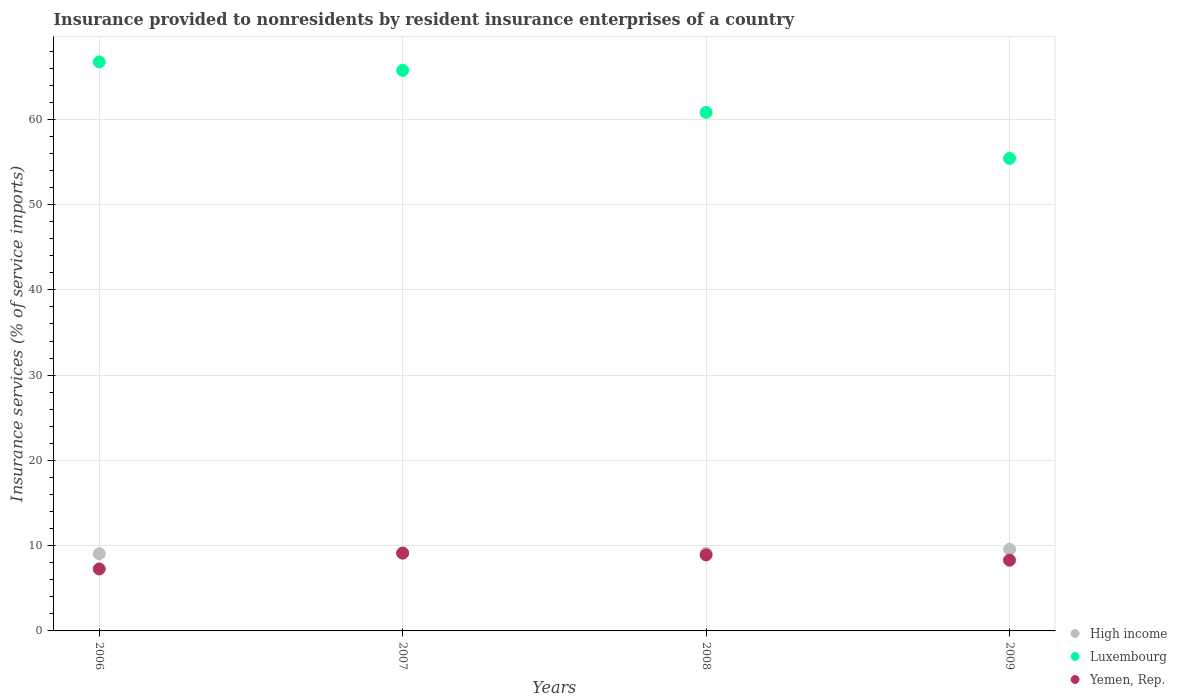How many different coloured dotlines are there?
Keep it short and to the point. 3. Is the number of dotlines equal to the number of legend labels?
Your response must be concise. Yes. What is the insurance provided to nonresidents in Yemen, Rep. in 2006?
Give a very brief answer. 7.27. Across all years, what is the maximum insurance provided to nonresidents in Luxembourg?
Your response must be concise. 66.73. Across all years, what is the minimum insurance provided to nonresidents in Yemen, Rep.?
Your answer should be compact. 7.27. In which year was the insurance provided to nonresidents in Luxembourg maximum?
Ensure brevity in your answer.  2006. What is the total insurance provided to nonresidents in Yemen, Rep. in the graph?
Your answer should be very brief. 33.59. What is the difference between the insurance provided to nonresidents in High income in 2006 and that in 2007?
Keep it short and to the point. -0.07. What is the difference between the insurance provided to nonresidents in Yemen, Rep. in 2006 and the insurance provided to nonresidents in High income in 2007?
Offer a terse response. -1.87. What is the average insurance provided to nonresidents in Luxembourg per year?
Provide a short and direct response. 62.17. In the year 2009, what is the difference between the insurance provided to nonresidents in Yemen, Rep. and insurance provided to nonresidents in Luxembourg?
Your response must be concise. -47.12. What is the ratio of the insurance provided to nonresidents in Yemen, Rep. in 2008 to that in 2009?
Your response must be concise. 1.07. Is the insurance provided to nonresidents in High income in 2007 less than that in 2008?
Provide a short and direct response. No. Is the difference between the insurance provided to nonresidents in Yemen, Rep. in 2007 and 2009 greater than the difference between the insurance provided to nonresidents in Luxembourg in 2007 and 2009?
Keep it short and to the point. No. What is the difference between the highest and the second highest insurance provided to nonresidents in High income?
Your answer should be very brief. 0.44. What is the difference between the highest and the lowest insurance provided to nonresidents in High income?
Your answer should be very brief. 0.52. Does the insurance provided to nonresidents in Yemen, Rep. monotonically increase over the years?
Your answer should be very brief. No. Is the insurance provided to nonresidents in Luxembourg strictly less than the insurance provided to nonresidents in Yemen, Rep. over the years?
Keep it short and to the point. No. How many dotlines are there?
Provide a short and direct response. 3. How many years are there in the graph?
Your answer should be compact. 4. What is the difference between two consecutive major ticks on the Y-axis?
Keep it short and to the point. 10. Are the values on the major ticks of Y-axis written in scientific E-notation?
Your answer should be compact. No. Does the graph contain any zero values?
Provide a succinct answer. No. Where does the legend appear in the graph?
Provide a succinct answer. Bottom right. What is the title of the graph?
Your answer should be compact. Insurance provided to nonresidents by resident insurance enterprises of a country. Does "Curacao" appear as one of the legend labels in the graph?
Provide a short and direct response. No. What is the label or title of the X-axis?
Offer a terse response. Years. What is the label or title of the Y-axis?
Ensure brevity in your answer.  Insurance services (% of service imports). What is the Insurance services (% of service imports) of High income in 2006?
Ensure brevity in your answer.  9.06. What is the Insurance services (% of service imports) of Luxembourg in 2006?
Ensure brevity in your answer.  66.73. What is the Insurance services (% of service imports) of Yemen, Rep. in 2006?
Offer a very short reply. 7.27. What is the Insurance services (% of service imports) of High income in 2007?
Keep it short and to the point. 9.13. What is the Insurance services (% of service imports) in Luxembourg in 2007?
Provide a short and direct response. 65.74. What is the Insurance services (% of service imports) of Yemen, Rep. in 2007?
Your answer should be very brief. 9.12. What is the Insurance services (% of service imports) of High income in 2008?
Provide a succinct answer. 9.11. What is the Insurance services (% of service imports) in Luxembourg in 2008?
Ensure brevity in your answer.  60.81. What is the Insurance services (% of service imports) in Yemen, Rep. in 2008?
Ensure brevity in your answer.  8.91. What is the Insurance services (% of service imports) of High income in 2009?
Keep it short and to the point. 9.58. What is the Insurance services (% of service imports) in Luxembourg in 2009?
Keep it short and to the point. 55.41. What is the Insurance services (% of service imports) in Yemen, Rep. in 2009?
Give a very brief answer. 8.29. Across all years, what is the maximum Insurance services (% of service imports) in High income?
Give a very brief answer. 9.58. Across all years, what is the maximum Insurance services (% of service imports) in Luxembourg?
Your answer should be compact. 66.73. Across all years, what is the maximum Insurance services (% of service imports) in Yemen, Rep.?
Your answer should be compact. 9.12. Across all years, what is the minimum Insurance services (% of service imports) in High income?
Your response must be concise. 9.06. Across all years, what is the minimum Insurance services (% of service imports) in Luxembourg?
Offer a terse response. 55.41. Across all years, what is the minimum Insurance services (% of service imports) in Yemen, Rep.?
Your answer should be very brief. 7.27. What is the total Insurance services (% of service imports) in High income in the graph?
Give a very brief answer. 36.87. What is the total Insurance services (% of service imports) of Luxembourg in the graph?
Your answer should be compact. 248.7. What is the total Insurance services (% of service imports) of Yemen, Rep. in the graph?
Keep it short and to the point. 33.59. What is the difference between the Insurance services (% of service imports) of High income in 2006 and that in 2007?
Your response must be concise. -0.07. What is the difference between the Insurance services (% of service imports) in Luxembourg in 2006 and that in 2007?
Offer a terse response. 0.99. What is the difference between the Insurance services (% of service imports) of Yemen, Rep. in 2006 and that in 2007?
Your answer should be compact. -1.86. What is the difference between the Insurance services (% of service imports) of High income in 2006 and that in 2008?
Make the answer very short. -0.05. What is the difference between the Insurance services (% of service imports) in Luxembourg in 2006 and that in 2008?
Your response must be concise. 5.92. What is the difference between the Insurance services (% of service imports) of Yemen, Rep. in 2006 and that in 2008?
Keep it short and to the point. -1.64. What is the difference between the Insurance services (% of service imports) in High income in 2006 and that in 2009?
Your answer should be very brief. -0.52. What is the difference between the Insurance services (% of service imports) of Luxembourg in 2006 and that in 2009?
Make the answer very short. 11.32. What is the difference between the Insurance services (% of service imports) in Yemen, Rep. in 2006 and that in 2009?
Ensure brevity in your answer.  -1.03. What is the difference between the Insurance services (% of service imports) of High income in 2007 and that in 2008?
Your answer should be compact. 0.03. What is the difference between the Insurance services (% of service imports) of Luxembourg in 2007 and that in 2008?
Ensure brevity in your answer.  4.93. What is the difference between the Insurance services (% of service imports) in Yemen, Rep. in 2007 and that in 2008?
Keep it short and to the point. 0.21. What is the difference between the Insurance services (% of service imports) of High income in 2007 and that in 2009?
Ensure brevity in your answer.  -0.44. What is the difference between the Insurance services (% of service imports) in Luxembourg in 2007 and that in 2009?
Your response must be concise. 10.33. What is the difference between the Insurance services (% of service imports) in Yemen, Rep. in 2007 and that in 2009?
Keep it short and to the point. 0.83. What is the difference between the Insurance services (% of service imports) of High income in 2008 and that in 2009?
Keep it short and to the point. -0.47. What is the difference between the Insurance services (% of service imports) in Luxembourg in 2008 and that in 2009?
Give a very brief answer. 5.4. What is the difference between the Insurance services (% of service imports) in Yemen, Rep. in 2008 and that in 2009?
Your response must be concise. 0.62. What is the difference between the Insurance services (% of service imports) in High income in 2006 and the Insurance services (% of service imports) in Luxembourg in 2007?
Your answer should be very brief. -56.68. What is the difference between the Insurance services (% of service imports) of High income in 2006 and the Insurance services (% of service imports) of Yemen, Rep. in 2007?
Offer a very short reply. -0.07. What is the difference between the Insurance services (% of service imports) of Luxembourg in 2006 and the Insurance services (% of service imports) of Yemen, Rep. in 2007?
Keep it short and to the point. 57.61. What is the difference between the Insurance services (% of service imports) in High income in 2006 and the Insurance services (% of service imports) in Luxembourg in 2008?
Give a very brief answer. -51.76. What is the difference between the Insurance services (% of service imports) in High income in 2006 and the Insurance services (% of service imports) in Yemen, Rep. in 2008?
Ensure brevity in your answer.  0.15. What is the difference between the Insurance services (% of service imports) in Luxembourg in 2006 and the Insurance services (% of service imports) in Yemen, Rep. in 2008?
Ensure brevity in your answer.  57.82. What is the difference between the Insurance services (% of service imports) in High income in 2006 and the Insurance services (% of service imports) in Luxembourg in 2009?
Provide a short and direct response. -46.36. What is the difference between the Insurance services (% of service imports) in High income in 2006 and the Insurance services (% of service imports) in Yemen, Rep. in 2009?
Make the answer very short. 0.77. What is the difference between the Insurance services (% of service imports) in Luxembourg in 2006 and the Insurance services (% of service imports) in Yemen, Rep. in 2009?
Offer a terse response. 58.44. What is the difference between the Insurance services (% of service imports) of High income in 2007 and the Insurance services (% of service imports) of Luxembourg in 2008?
Make the answer very short. -51.68. What is the difference between the Insurance services (% of service imports) of High income in 2007 and the Insurance services (% of service imports) of Yemen, Rep. in 2008?
Offer a terse response. 0.22. What is the difference between the Insurance services (% of service imports) in Luxembourg in 2007 and the Insurance services (% of service imports) in Yemen, Rep. in 2008?
Offer a terse response. 56.83. What is the difference between the Insurance services (% of service imports) of High income in 2007 and the Insurance services (% of service imports) of Luxembourg in 2009?
Offer a terse response. -46.28. What is the difference between the Insurance services (% of service imports) of High income in 2007 and the Insurance services (% of service imports) of Yemen, Rep. in 2009?
Provide a short and direct response. 0.84. What is the difference between the Insurance services (% of service imports) in Luxembourg in 2007 and the Insurance services (% of service imports) in Yemen, Rep. in 2009?
Your answer should be very brief. 57.45. What is the difference between the Insurance services (% of service imports) of High income in 2008 and the Insurance services (% of service imports) of Luxembourg in 2009?
Provide a succinct answer. -46.31. What is the difference between the Insurance services (% of service imports) in High income in 2008 and the Insurance services (% of service imports) in Yemen, Rep. in 2009?
Ensure brevity in your answer.  0.81. What is the difference between the Insurance services (% of service imports) of Luxembourg in 2008 and the Insurance services (% of service imports) of Yemen, Rep. in 2009?
Provide a short and direct response. 52.52. What is the average Insurance services (% of service imports) in High income per year?
Keep it short and to the point. 9.22. What is the average Insurance services (% of service imports) of Luxembourg per year?
Your response must be concise. 62.17. What is the average Insurance services (% of service imports) of Yemen, Rep. per year?
Keep it short and to the point. 8.4. In the year 2006, what is the difference between the Insurance services (% of service imports) in High income and Insurance services (% of service imports) in Luxembourg?
Keep it short and to the point. -57.67. In the year 2006, what is the difference between the Insurance services (% of service imports) of High income and Insurance services (% of service imports) of Yemen, Rep.?
Your answer should be very brief. 1.79. In the year 2006, what is the difference between the Insurance services (% of service imports) in Luxembourg and Insurance services (% of service imports) in Yemen, Rep.?
Your answer should be compact. 59.46. In the year 2007, what is the difference between the Insurance services (% of service imports) of High income and Insurance services (% of service imports) of Luxembourg?
Make the answer very short. -56.61. In the year 2007, what is the difference between the Insurance services (% of service imports) in High income and Insurance services (% of service imports) in Yemen, Rep.?
Offer a very short reply. 0.01. In the year 2007, what is the difference between the Insurance services (% of service imports) of Luxembourg and Insurance services (% of service imports) of Yemen, Rep.?
Provide a short and direct response. 56.62. In the year 2008, what is the difference between the Insurance services (% of service imports) of High income and Insurance services (% of service imports) of Luxembourg?
Offer a terse response. -51.71. In the year 2008, what is the difference between the Insurance services (% of service imports) of High income and Insurance services (% of service imports) of Yemen, Rep.?
Offer a terse response. 0.2. In the year 2008, what is the difference between the Insurance services (% of service imports) in Luxembourg and Insurance services (% of service imports) in Yemen, Rep.?
Make the answer very short. 51.9. In the year 2009, what is the difference between the Insurance services (% of service imports) in High income and Insurance services (% of service imports) in Luxembourg?
Provide a succinct answer. -45.84. In the year 2009, what is the difference between the Insurance services (% of service imports) of High income and Insurance services (% of service imports) of Yemen, Rep.?
Your response must be concise. 1.28. In the year 2009, what is the difference between the Insurance services (% of service imports) of Luxembourg and Insurance services (% of service imports) of Yemen, Rep.?
Provide a short and direct response. 47.12. What is the ratio of the Insurance services (% of service imports) in Luxembourg in 2006 to that in 2007?
Ensure brevity in your answer.  1.01. What is the ratio of the Insurance services (% of service imports) in Yemen, Rep. in 2006 to that in 2007?
Ensure brevity in your answer.  0.8. What is the ratio of the Insurance services (% of service imports) in High income in 2006 to that in 2008?
Offer a very short reply. 0.99. What is the ratio of the Insurance services (% of service imports) in Luxembourg in 2006 to that in 2008?
Your response must be concise. 1.1. What is the ratio of the Insurance services (% of service imports) in Yemen, Rep. in 2006 to that in 2008?
Your answer should be compact. 0.82. What is the ratio of the Insurance services (% of service imports) of High income in 2006 to that in 2009?
Make the answer very short. 0.95. What is the ratio of the Insurance services (% of service imports) of Luxembourg in 2006 to that in 2009?
Ensure brevity in your answer.  1.2. What is the ratio of the Insurance services (% of service imports) of Yemen, Rep. in 2006 to that in 2009?
Provide a succinct answer. 0.88. What is the ratio of the Insurance services (% of service imports) of Luxembourg in 2007 to that in 2008?
Ensure brevity in your answer.  1.08. What is the ratio of the Insurance services (% of service imports) of High income in 2007 to that in 2009?
Give a very brief answer. 0.95. What is the ratio of the Insurance services (% of service imports) in Luxembourg in 2007 to that in 2009?
Ensure brevity in your answer.  1.19. What is the ratio of the Insurance services (% of service imports) of Yemen, Rep. in 2007 to that in 2009?
Provide a short and direct response. 1.1. What is the ratio of the Insurance services (% of service imports) of High income in 2008 to that in 2009?
Ensure brevity in your answer.  0.95. What is the ratio of the Insurance services (% of service imports) in Luxembourg in 2008 to that in 2009?
Ensure brevity in your answer.  1.1. What is the ratio of the Insurance services (% of service imports) of Yemen, Rep. in 2008 to that in 2009?
Your response must be concise. 1.07. What is the difference between the highest and the second highest Insurance services (% of service imports) of High income?
Provide a succinct answer. 0.44. What is the difference between the highest and the second highest Insurance services (% of service imports) of Yemen, Rep.?
Ensure brevity in your answer.  0.21. What is the difference between the highest and the lowest Insurance services (% of service imports) of High income?
Your response must be concise. 0.52. What is the difference between the highest and the lowest Insurance services (% of service imports) in Luxembourg?
Your answer should be very brief. 11.32. What is the difference between the highest and the lowest Insurance services (% of service imports) in Yemen, Rep.?
Provide a succinct answer. 1.86. 